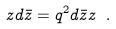Convert formula to latex. <formula><loc_0><loc_0><loc_500><loc_500>z d \bar { z } = q ^ { 2 } d \bar { z } z \ .</formula> 